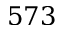Convert formula to latex. <formula><loc_0><loc_0><loc_500><loc_500>5 7 3</formula> 